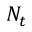Convert formula to latex. <formula><loc_0><loc_0><loc_500><loc_500>N _ { t }</formula> 